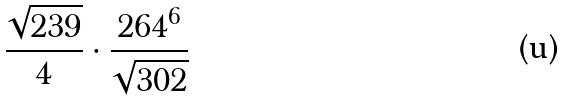<formula> <loc_0><loc_0><loc_500><loc_500>\frac { \sqrt { 2 3 9 } } { 4 } \cdot \frac { 2 6 4 ^ { 6 } } { \sqrt { 3 0 2 } }</formula> 